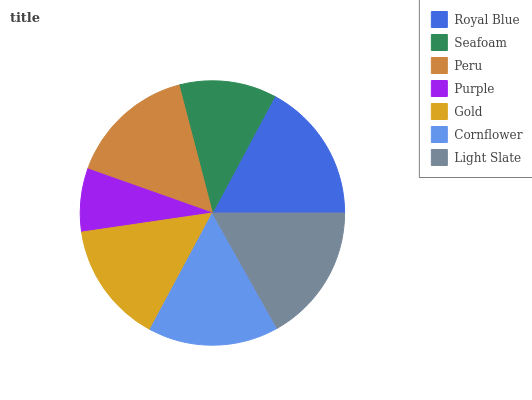Is Purple the minimum?
Answer yes or no. Yes. Is Royal Blue the maximum?
Answer yes or no. Yes. Is Seafoam the minimum?
Answer yes or no. No. Is Seafoam the maximum?
Answer yes or no. No. Is Royal Blue greater than Seafoam?
Answer yes or no. Yes. Is Seafoam less than Royal Blue?
Answer yes or no. Yes. Is Seafoam greater than Royal Blue?
Answer yes or no. No. Is Royal Blue less than Seafoam?
Answer yes or no. No. Is Peru the high median?
Answer yes or no. Yes. Is Peru the low median?
Answer yes or no. Yes. Is Royal Blue the high median?
Answer yes or no. No. Is Light Slate the low median?
Answer yes or no. No. 